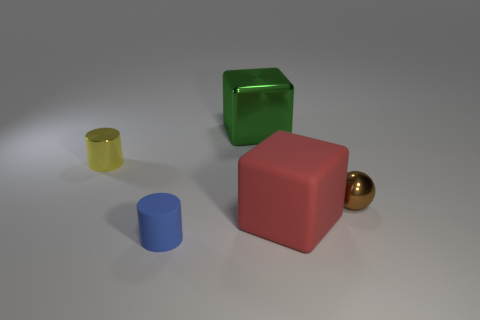There is a big red object that is the same shape as the large green object; what is it made of?
Provide a short and direct response. Rubber. The thing that is both to the left of the big green shiny cube and in front of the metallic cylinder has what shape?
Provide a short and direct response. Cylinder. The large thing that is behind the sphere has what shape?
Offer a terse response. Cube. How many small objects are to the left of the green cube and on the right side of the red rubber thing?
Your answer should be compact. 0. Is the size of the brown shiny ball the same as the green shiny block that is behind the rubber cube?
Provide a short and direct response. No. There is a cube in front of the small brown ball behind the cylinder that is on the right side of the yellow metallic cylinder; what size is it?
Provide a succinct answer. Large. There is a cylinder that is behind the tiny brown object; how big is it?
Provide a succinct answer. Small. What shape is the yellow thing that is made of the same material as the green object?
Give a very brief answer. Cylinder. Are the large cube that is behind the big matte cube and the small brown ball made of the same material?
Your response must be concise. Yes. How many other objects are there of the same material as the tiny ball?
Provide a succinct answer. 2. 